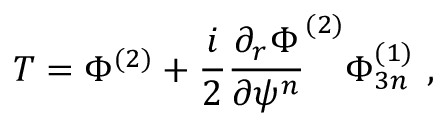<formula> <loc_0><loc_0><loc_500><loc_500>T = \Phi ^ { ( 2 ) } + \frac { i } { 2 } \frac { \partial _ { r } \Phi } { \partial \psi ^ { n } } ^ { ( 2 ) } \Phi _ { 3 n } ^ { ( 1 ) } \, ,</formula> 